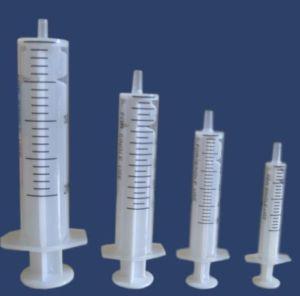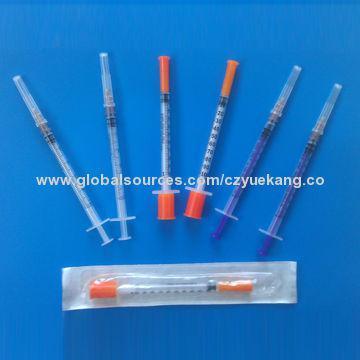The first image is the image on the left, the second image is the image on the right. Considering the images on both sides, is "There are more than twelve syringes in total." valid? Answer yes or no. No. The first image is the image on the left, the second image is the image on the right. Examine the images to the left and right. Is the description "There are at least fourteen syringes with needle on them." accurate? Answer yes or no. No. 